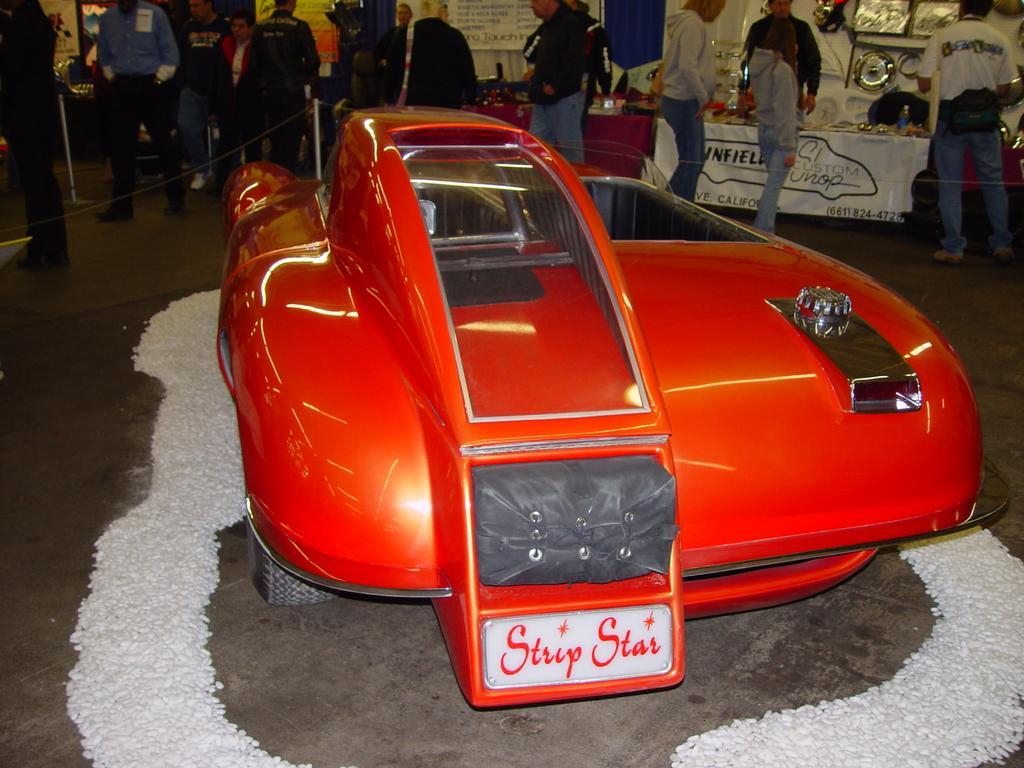Describe this image in one or two sentences. In the center of the image, we can see a vehicle on the road and in the background, there are people and we can see banners, frames and we can see some other objects and there are tables, poles and we can see a fence. 